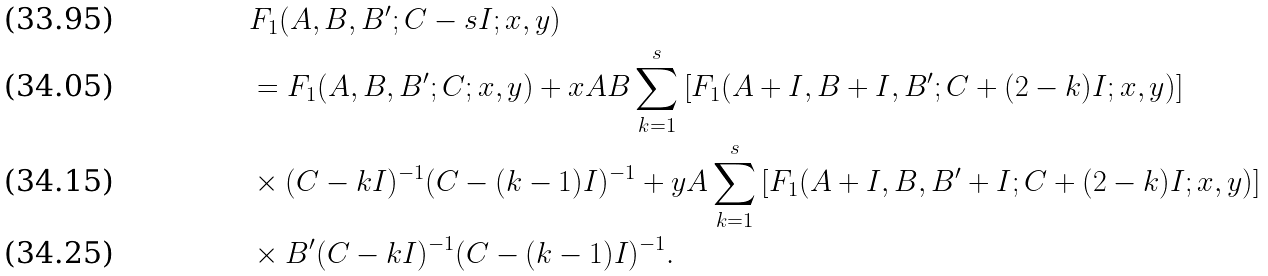Convert formula to latex. <formula><loc_0><loc_0><loc_500><loc_500>& F _ { 1 } ( A , B , B ^ { \prime } ; C - s I ; x , y ) \\ & = F _ { 1 } ( A , B , B ^ { \prime } ; C ; x , y ) + x A B \sum _ { k = 1 } ^ { s } \left [ F _ { 1 } ( A + I , B + I , B ^ { \prime } ; C + ( 2 - k ) I ; x , y ) \right ] \\ & \times { ( C - k I ) ^ { - 1 } ( C - ( k - 1 ) I ) ^ { - 1 } } + y A \sum _ { k = 1 } ^ { s } \left [ F _ { 1 } ( A + I , B , B ^ { \prime } + I ; C + ( 2 - k ) I ; x , y ) \right ] \\ & \times B ^ { \prime } { ( C - k I ) ^ { - 1 } ( C - ( k - 1 ) I ) ^ { - 1 } } .</formula> 